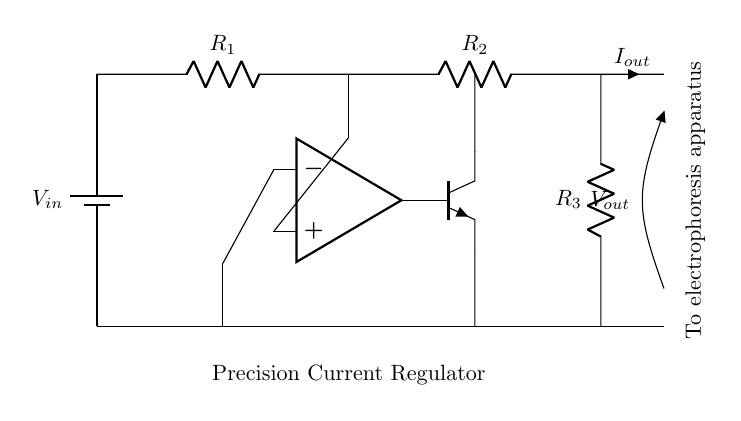What is the type of power supply used in this circuit? The circuit uses a battery as the power supply, as indicated by the symbol for the battery with the label V in at the top left corner.
Answer: battery What are the components connected in series to the output? The output branches from R2 and R3, forming part of a series arrangement. R2 connects to R3, which leads to the output terminal where I out and V out are measured.
Answer: R2, R3 What is the purpose of the operational amplifier in this circuit? The operational amplifier is used to regulate the current by comparing the input voltage and controlling the transistor's operation to maintain the desired current output.
Answer: regulate current How many resistors are present in this circuit? There are three resistors labeled R1, R2, and R3 as shown in the circuit diagram, each fulfilling a specific role in current regulation.
Answer: three Which terminal does the precision current regulator output? The output is provided at the terminal labeled I out, which flows to the electrophoresis apparatus as indicated by the label near the output path.
Answer: I out What is the role of the transistor in this circuit? The transistor amplifies or regulates the control signal from the operational amplifier, allowing it to manage the output current efficiently, essential for maintaining precision in the current regulator function.
Answer: regulate output current 